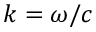Convert formula to latex. <formula><loc_0><loc_0><loc_500><loc_500>k = \omega / c</formula> 